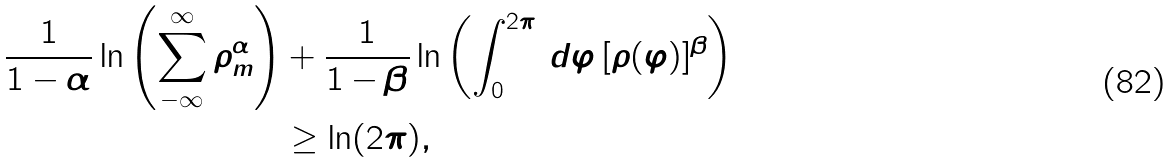Convert formula to latex. <formula><loc_0><loc_0><loc_500><loc_500>\frac { 1 } { 1 - \alpha } \ln \left ( \sum _ { - \infty } ^ { \infty } \rho _ { m } ^ { \alpha } \right ) & + \frac { 1 } { 1 - \beta } \ln \left ( \int _ { 0 } ^ { 2 \pi } \, d \varphi \, [ { \rho } ( \varphi ) ] ^ { \beta } \right ) \\ & \geq \ln ( 2 \pi ) ,</formula> 